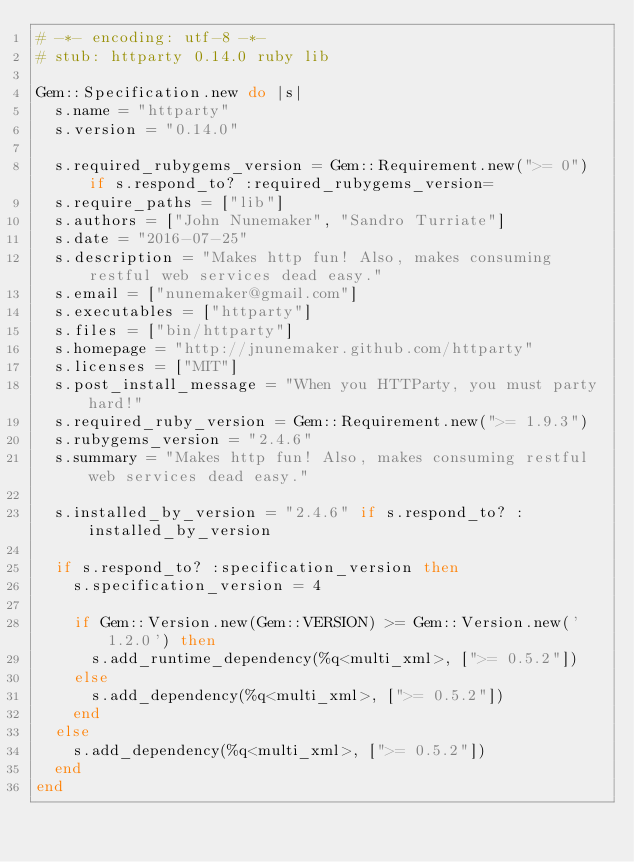Convert code to text. <code><loc_0><loc_0><loc_500><loc_500><_Ruby_># -*- encoding: utf-8 -*-
# stub: httparty 0.14.0 ruby lib

Gem::Specification.new do |s|
  s.name = "httparty"
  s.version = "0.14.0"

  s.required_rubygems_version = Gem::Requirement.new(">= 0") if s.respond_to? :required_rubygems_version=
  s.require_paths = ["lib"]
  s.authors = ["John Nunemaker", "Sandro Turriate"]
  s.date = "2016-07-25"
  s.description = "Makes http fun! Also, makes consuming restful web services dead easy."
  s.email = ["nunemaker@gmail.com"]
  s.executables = ["httparty"]
  s.files = ["bin/httparty"]
  s.homepage = "http://jnunemaker.github.com/httparty"
  s.licenses = ["MIT"]
  s.post_install_message = "When you HTTParty, you must party hard!"
  s.required_ruby_version = Gem::Requirement.new(">= 1.9.3")
  s.rubygems_version = "2.4.6"
  s.summary = "Makes http fun! Also, makes consuming restful web services dead easy."

  s.installed_by_version = "2.4.6" if s.respond_to? :installed_by_version

  if s.respond_to? :specification_version then
    s.specification_version = 4

    if Gem::Version.new(Gem::VERSION) >= Gem::Version.new('1.2.0') then
      s.add_runtime_dependency(%q<multi_xml>, [">= 0.5.2"])
    else
      s.add_dependency(%q<multi_xml>, [">= 0.5.2"])
    end
  else
    s.add_dependency(%q<multi_xml>, [">= 0.5.2"])
  end
end
</code> 